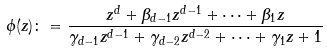Convert formula to latex. <formula><loc_0><loc_0><loc_500><loc_500>\phi ( z ) \colon = \frac { z ^ { d } + \beta _ { d - 1 } z ^ { d - 1 } + \cdots + \beta _ { 1 } z } { \gamma _ { d - 1 } z ^ { d - 1 } + \gamma _ { d - 2 } z ^ { d - 2 } + \cdots + \gamma _ { 1 } z + 1 }</formula> 